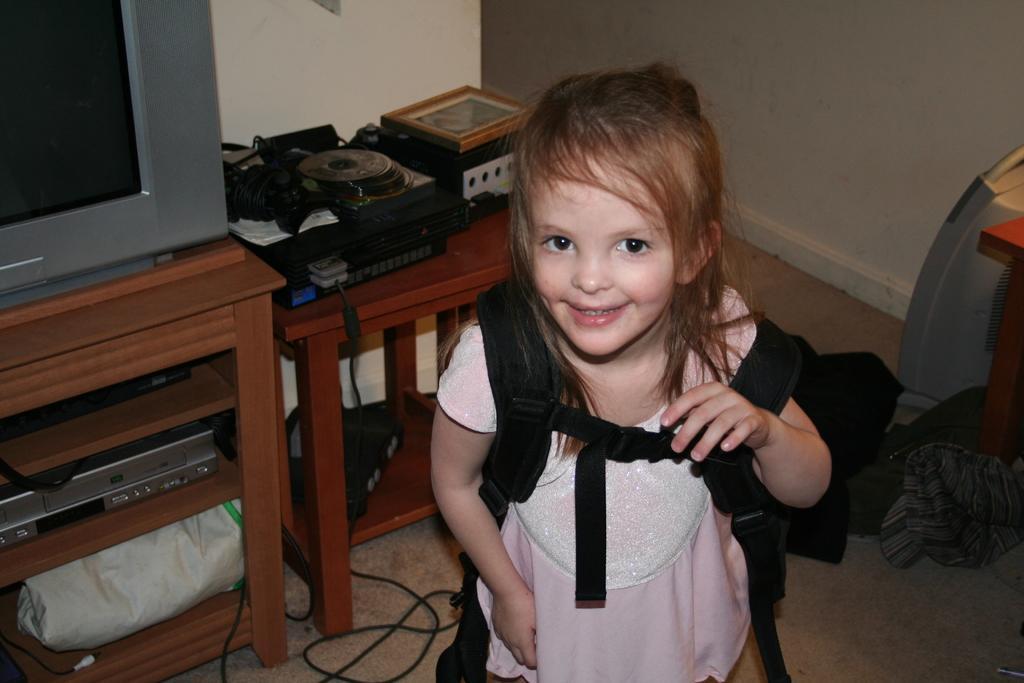Describe this image in one or two sentences. In the center of the image there is a girl wearing a bag. In the background of the image there is wall. There is a TV on a TV stand. There is a table on which there are objects. At the bottom of the image there is a carpet. To the right side of the image there is some object. 